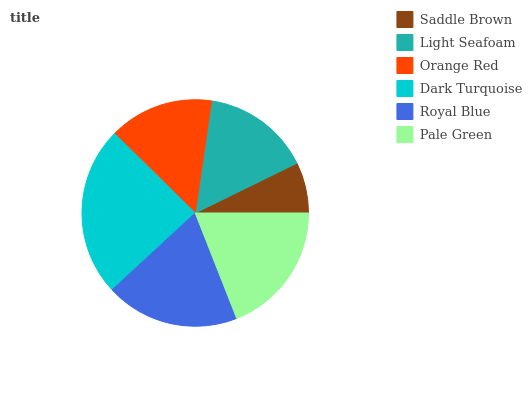Is Saddle Brown the minimum?
Answer yes or no. Yes. Is Dark Turquoise the maximum?
Answer yes or no. Yes. Is Light Seafoam the minimum?
Answer yes or no. No. Is Light Seafoam the maximum?
Answer yes or no. No. Is Light Seafoam greater than Saddle Brown?
Answer yes or no. Yes. Is Saddle Brown less than Light Seafoam?
Answer yes or no. Yes. Is Saddle Brown greater than Light Seafoam?
Answer yes or no. No. Is Light Seafoam less than Saddle Brown?
Answer yes or no. No. Is Pale Green the high median?
Answer yes or no. Yes. Is Light Seafoam the low median?
Answer yes or no. Yes. Is Light Seafoam the high median?
Answer yes or no. No. Is Royal Blue the low median?
Answer yes or no. No. 